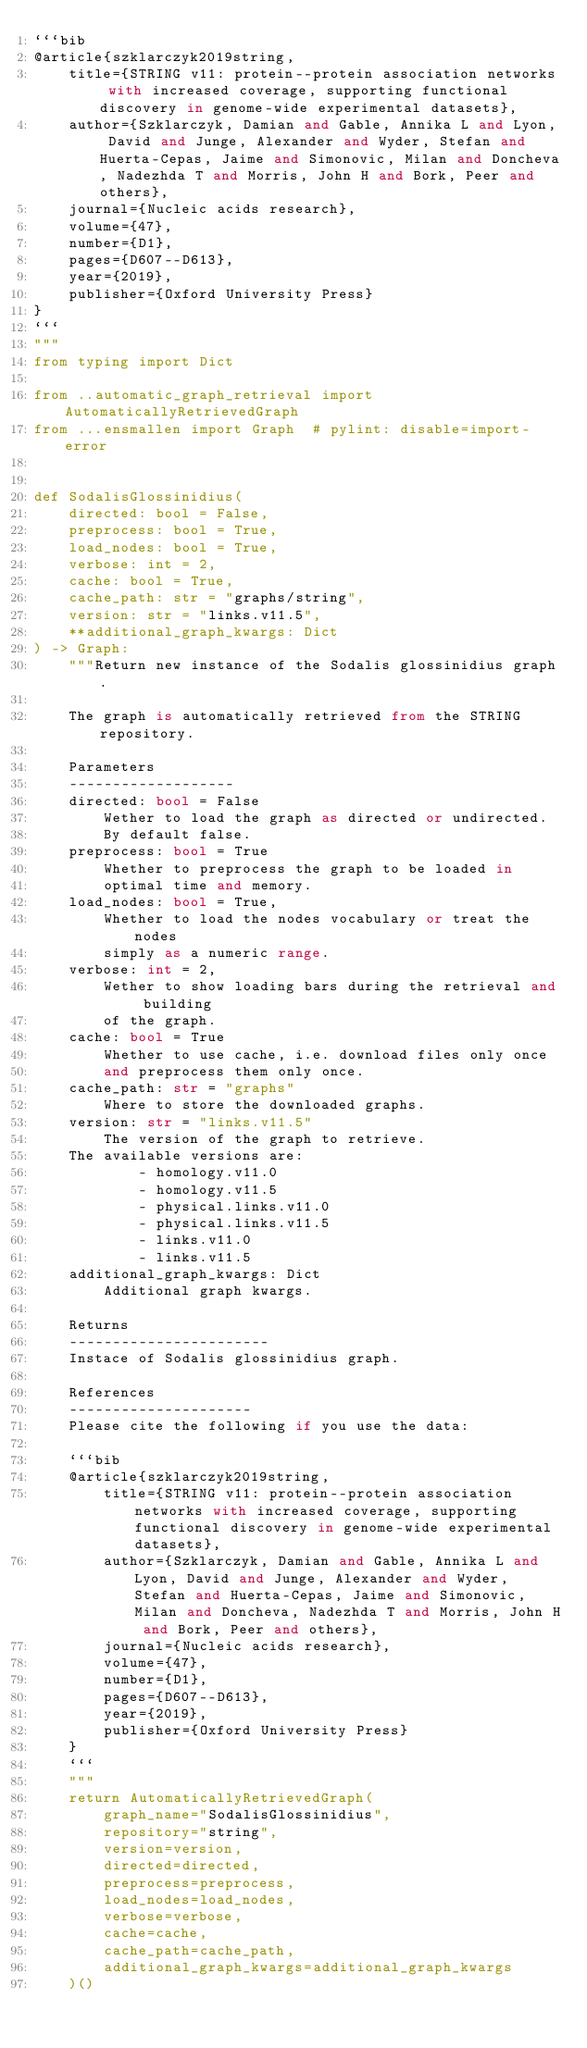Convert code to text. <code><loc_0><loc_0><loc_500><loc_500><_Python_>```bib
@article{szklarczyk2019string,
    title={STRING v11: protein--protein association networks with increased coverage, supporting functional discovery in genome-wide experimental datasets},
    author={Szklarczyk, Damian and Gable, Annika L and Lyon, David and Junge, Alexander and Wyder, Stefan and Huerta-Cepas, Jaime and Simonovic, Milan and Doncheva, Nadezhda T and Morris, John H and Bork, Peer and others},
    journal={Nucleic acids research},
    volume={47},
    number={D1},
    pages={D607--D613},
    year={2019},
    publisher={Oxford University Press}
}
```
"""
from typing import Dict

from ..automatic_graph_retrieval import AutomaticallyRetrievedGraph
from ...ensmallen import Graph  # pylint: disable=import-error


def SodalisGlossinidius(
    directed: bool = False,
    preprocess: bool = True,
    load_nodes: bool = True,
    verbose: int = 2,
    cache: bool = True,
    cache_path: str = "graphs/string",
    version: str = "links.v11.5",
    **additional_graph_kwargs: Dict
) -> Graph:
    """Return new instance of the Sodalis glossinidius graph.

    The graph is automatically retrieved from the STRING repository.	

    Parameters
    -------------------
    directed: bool = False
        Wether to load the graph as directed or undirected.
        By default false.
    preprocess: bool = True
        Whether to preprocess the graph to be loaded in 
        optimal time and memory.
    load_nodes: bool = True,
        Whether to load the nodes vocabulary or treat the nodes
        simply as a numeric range.
    verbose: int = 2,
        Wether to show loading bars during the retrieval and building
        of the graph.
    cache: bool = True
        Whether to use cache, i.e. download files only once
        and preprocess them only once.
    cache_path: str = "graphs"
        Where to store the downloaded graphs.
    version: str = "links.v11.5"
        The version of the graph to retrieve.		
	The available versions are:
			- homology.v11.0
			- homology.v11.5
			- physical.links.v11.0
			- physical.links.v11.5
			- links.v11.0
			- links.v11.5
    additional_graph_kwargs: Dict
        Additional graph kwargs.

    Returns
    -----------------------
    Instace of Sodalis glossinidius graph.

	References
	---------------------
	Please cite the following if you use the data:
	
	```bib
	@article{szklarczyk2019string,
	    title={STRING v11: protein--protein association networks with increased coverage, supporting functional discovery in genome-wide experimental datasets},
	    author={Szklarczyk, Damian and Gable, Annika L and Lyon, David and Junge, Alexander and Wyder, Stefan and Huerta-Cepas, Jaime and Simonovic, Milan and Doncheva, Nadezhda T and Morris, John H and Bork, Peer and others},
	    journal={Nucleic acids research},
	    volume={47},
	    number={D1},
	    pages={D607--D613},
	    year={2019},
	    publisher={Oxford University Press}
	}
	```
    """
    return AutomaticallyRetrievedGraph(
        graph_name="SodalisGlossinidius",
        repository="string",
        version=version,
        directed=directed,
        preprocess=preprocess,
        load_nodes=load_nodes,
        verbose=verbose,
        cache=cache,
        cache_path=cache_path,
        additional_graph_kwargs=additional_graph_kwargs
    )()
</code> 